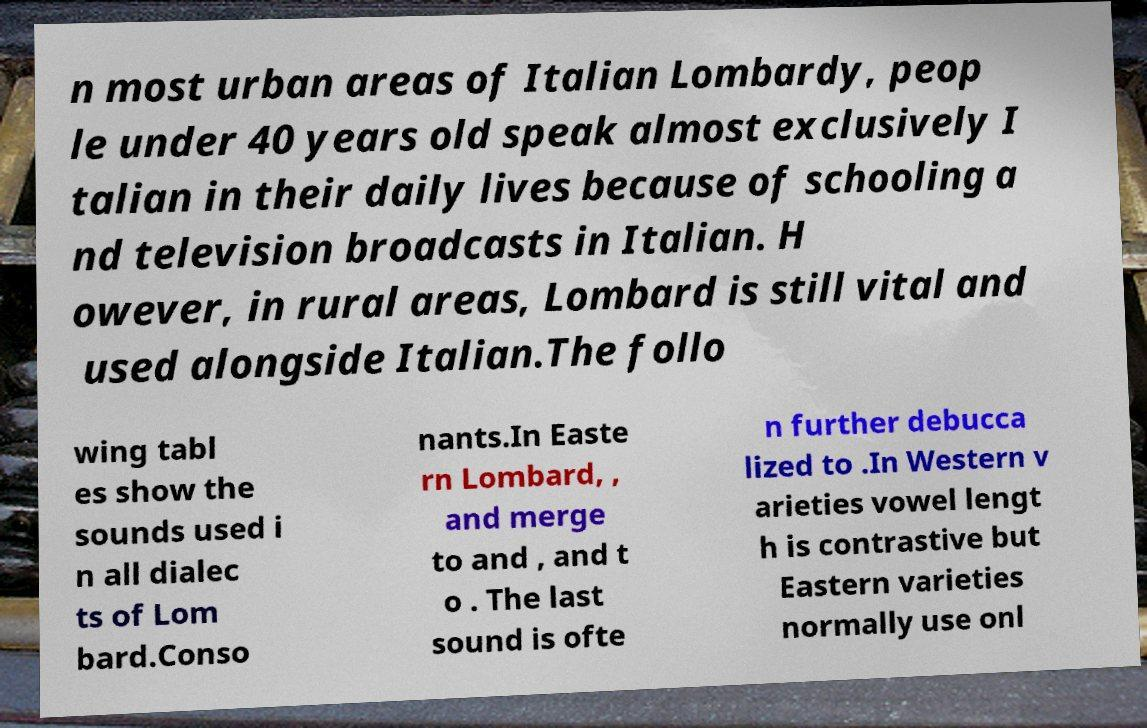Please read and relay the text visible in this image. What does it say? n most urban areas of Italian Lombardy, peop le under 40 years old speak almost exclusively I talian in their daily lives because of schooling a nd television broadcasts in Italian. H owever, in rural areas, Lombard is still vital and used alongside Italian.The follo wing tabl es show the sounds used i n all dialec ts of Lom bard.Conso nants.In Easte rn Lombard, , and merge to and , and t o . The last sound is ofte n further debucca lized to .In Western v arieties vowel lengt h is contrastive but Eastern varieties normally use onl 